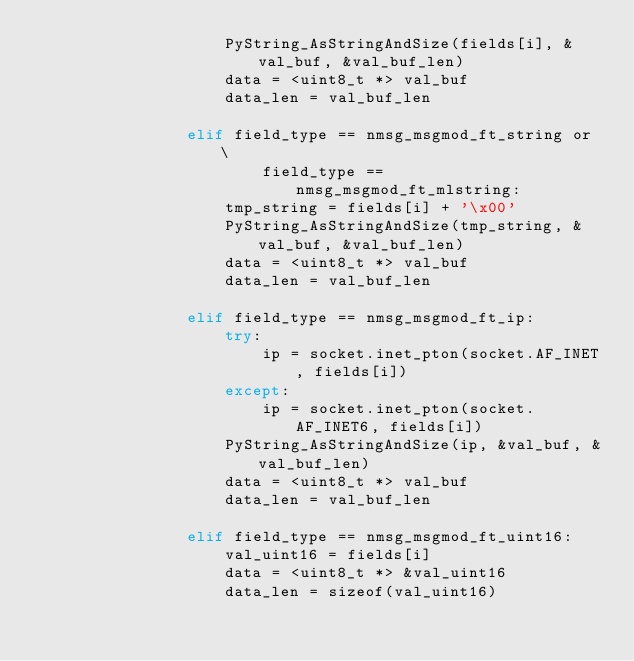<code> <loc_0><loc_0><loc_500><loc_500><_Cython_>                    PyString_AsStringAndSize(fields[i], &val_buf, &val_buf_len)
                    data = <uint8_t *> val_buf
                    data_len = val_buf_len

                elif field_type == nmsg_msgmod_ft_string or \
                        field_type == nmsg_msgmod_ft_mlstring:
                    tmp_string = fields[i] + '\x00'
                    PyString_AsStringAndSize(tmp_string, &val_buf, &val_buf_len)
                    data = <uint8_t *> val_buf
                    data_len = val_buf_len

                elif field_type == nmsg_msgmod_ft_ip:
                    try:
                        ip = socket.inet_pton(socket.AF_INET, fields[i])
                    except:
                        ip = socket.inet_pton(socket.AF_INET6, fields[i])
                    PyString_AsStringAndSize(ip, &val_buf, &val_buf_len)
                    data = <uint8_t *> val_buf
                    data_len = val_buf_len

                elif field_type == nmsg_msgmod_ft_uint16:
                    val_uint16 = fields[i]
                    data = <uint8_t *> &val_uint16
                    data_len = sizeof(val_uint16)
</code> 